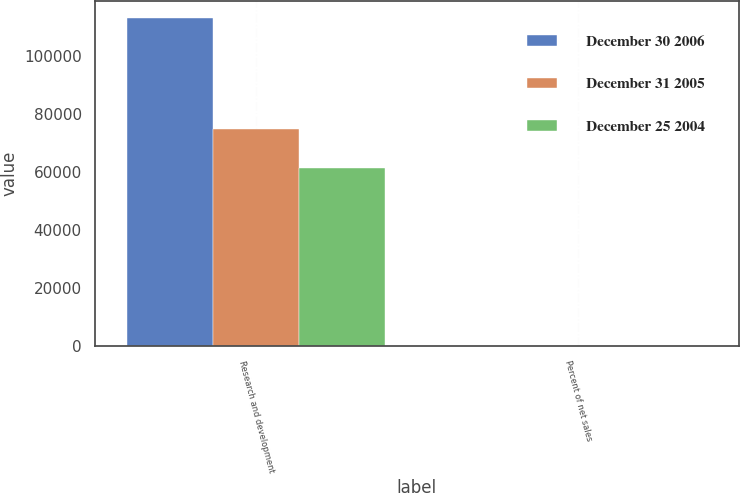<chart> <loc_0><loc_0><loc_500><loc_500><stacked_bar_chart><ecel><fcel>Research and development<fcel>Percent of net sales<nl><fcel>December 30 2006<fcel>113314<fcel>6.4<nl><fcel>December 31 2005<fcel>74879<fcel>7.3<nl><fcel>December 25 2004<fcel>61580<fcel>8<nl></chart> 